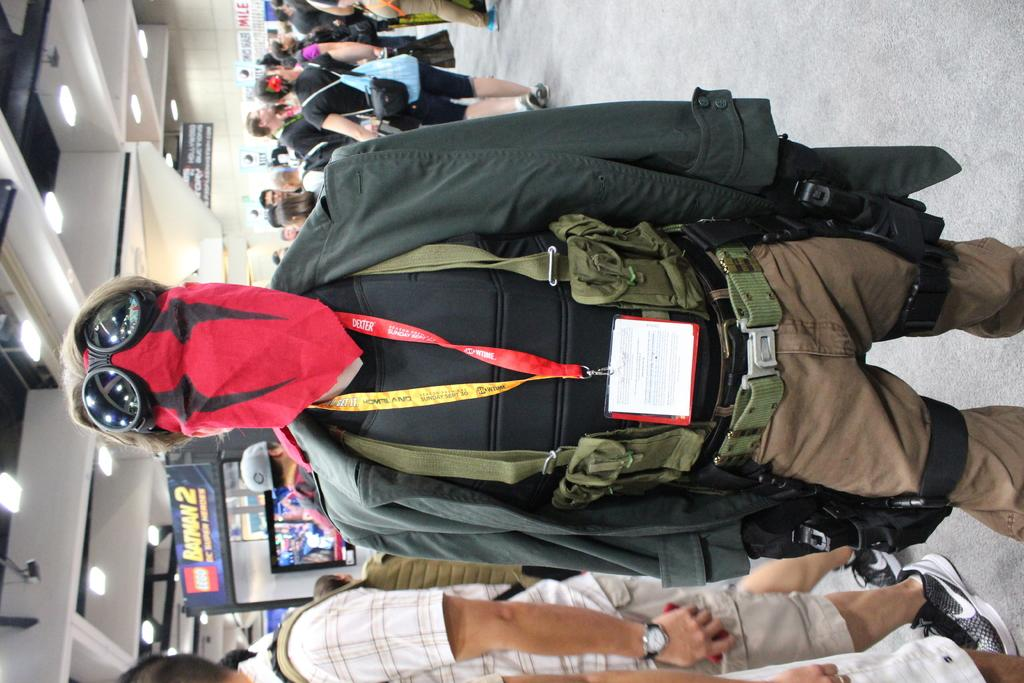<image>
Relay a brief, clear account of the picture shown. Behind the masked man is a sign for batman 2. 